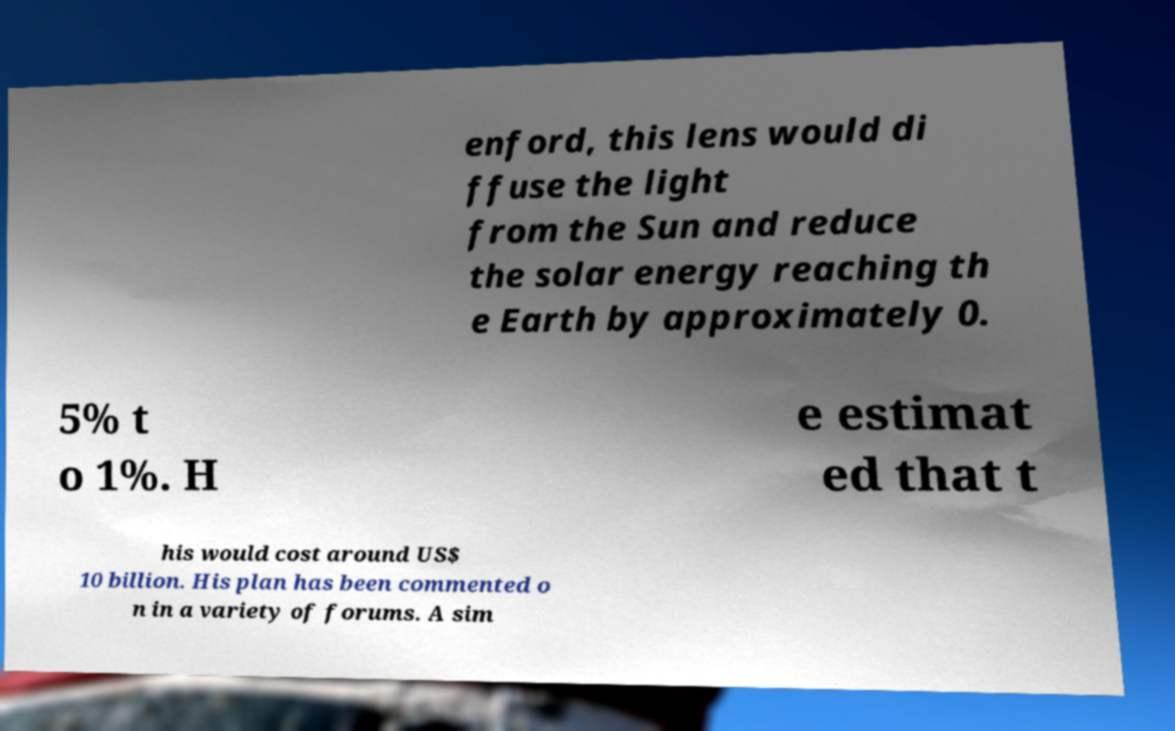Please identify and transcribe the text found in this image. enford, this lens would di ffuse the light from the Sun and reduce the solar energy reaching th e Earth by approximately 0. 5% t o 1%. H e estimat ed that t his would cost around US$ 10 billion. His plan has been commented o n in a variety of forums. A sim 